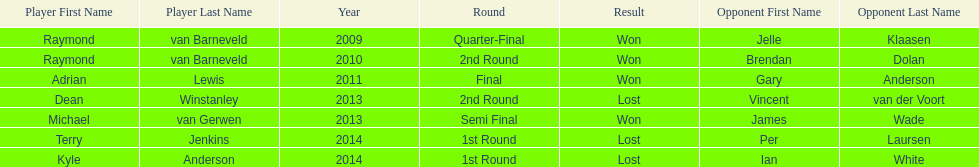Who were all the players? Raymond van Barneveld, Raymond van Barneveld, Adrian Lewis, Dean Winstanley, Michael van Gerwen, Terry Jenkins, Kyle Anderson. Which of these played in 2014? Terry Jenkins, Kyle Anderson. Who were their opponents? Per Laursen, Ian White. Which of these beat terry jenkins? Per Laursen. 